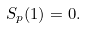Convert formula to latex. <formula><loc_0><loc_0><loc_500><loc_500>S _ { p } ( 1 ) = 0 .</formula> 